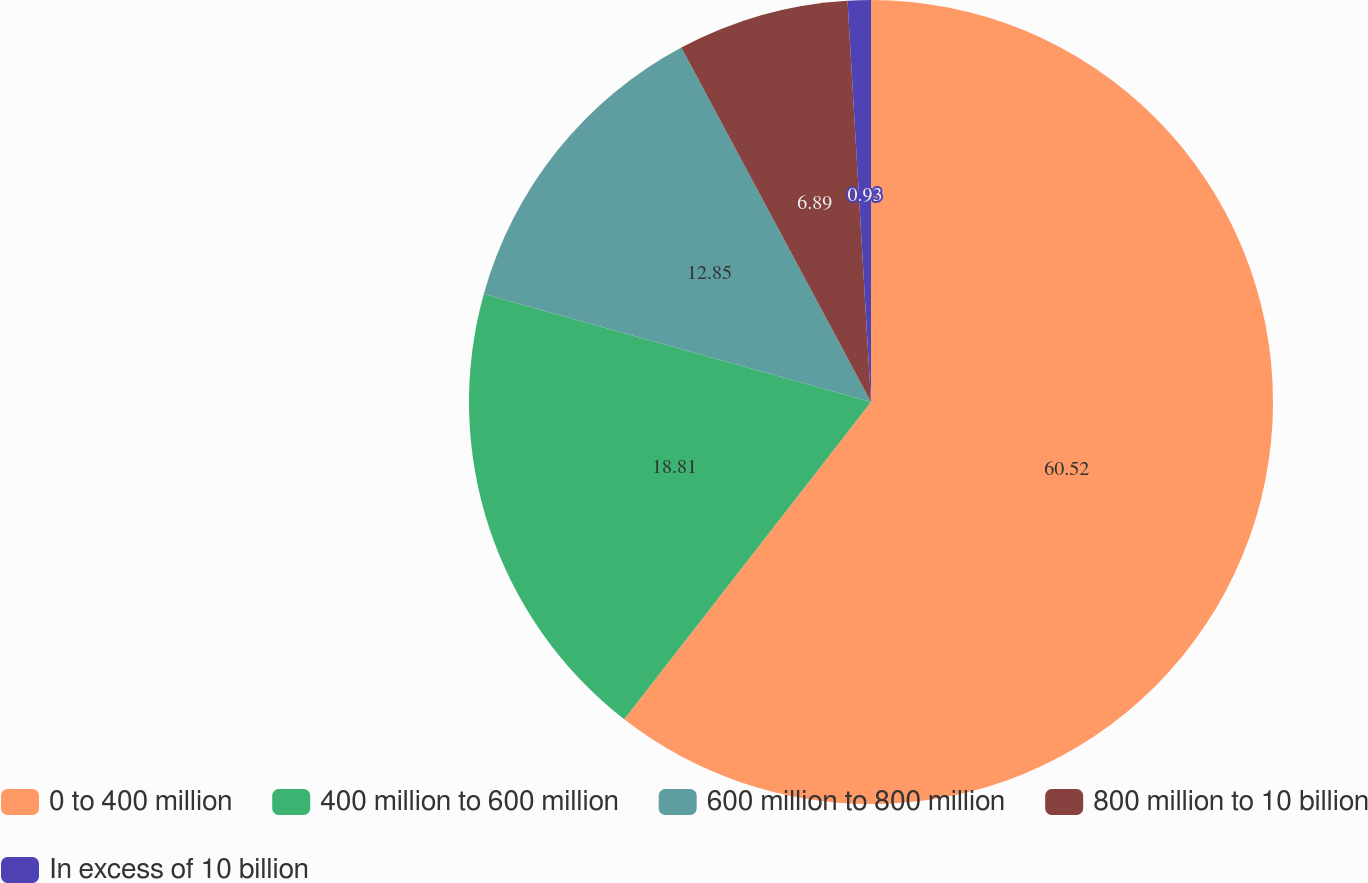Convert chart to OTSL. <chart><loc_0><loc_0><loc_500><loc_500><pie_chart><fcel>0 to 400 million<fcel>400 million to 600 million<fcel>600 million to 800 million<fcel>800 million to 10 billion<fcel>In excess of 10 billion<nl><fcel>60.52%<fcel>18.81%<fcel>12.85%<fcel>6.89%<fcel>0.93%<nl></chart> 